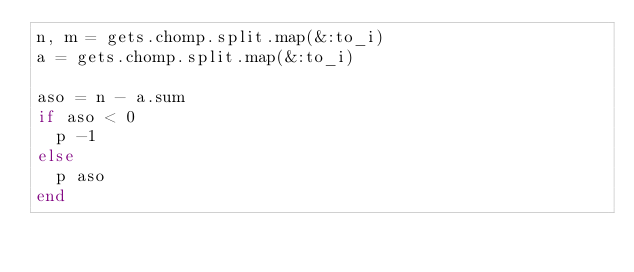<code> <loc_0><loc_0><loc_500><loc_500><_Ruby_>n, m = gets.chomp.split.map(&:to_i)
a = gets.chomp.split.map(&:to_i)

aso = n - a.sum
if aso < 0
  p -1
else
  p aso
end
</code> 